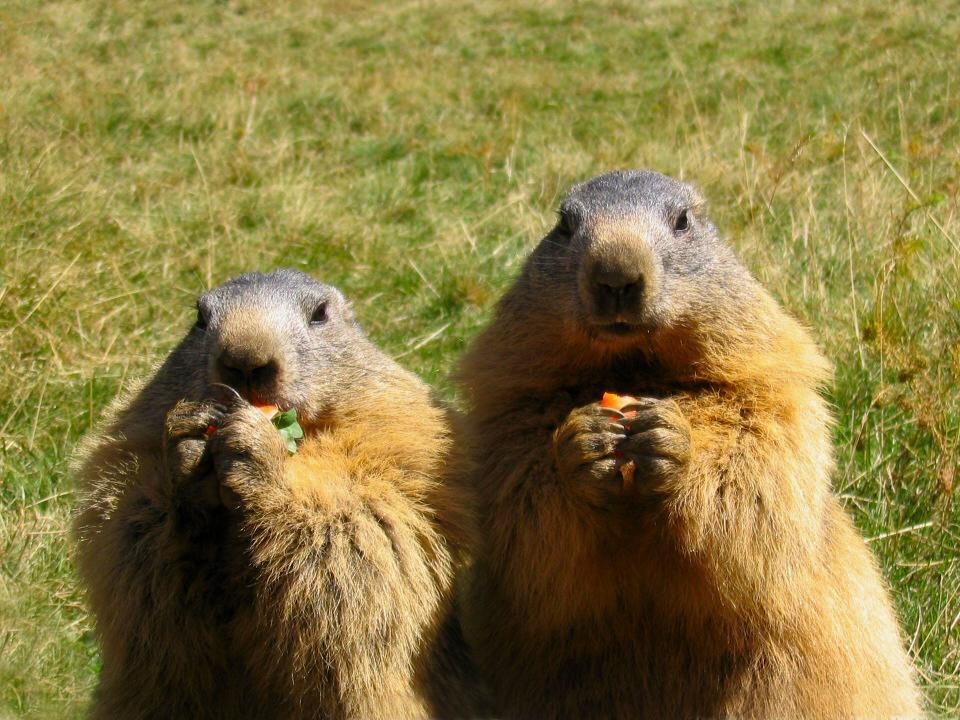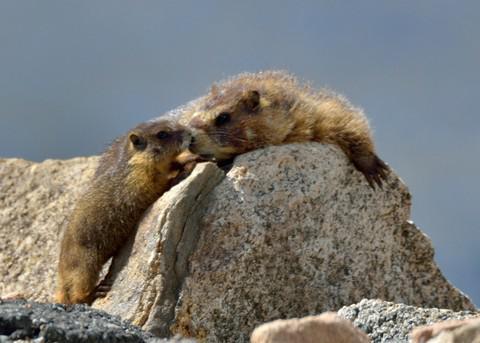The first image is the image on the left, the second image is the image on the right. Considering the images on both sides, is "Left image contains two marmots, which are upright and posed together, and the one on the left of the picture looks shorter than the marmot on the right." valid? Answer yes or no. Yes. The first image is the image on the left, the second image is the image on the right. Analyze the images presented: Is the assertion "The animals in the image on the right are standing on their hind legs." valid? Answer yes or no. No. 